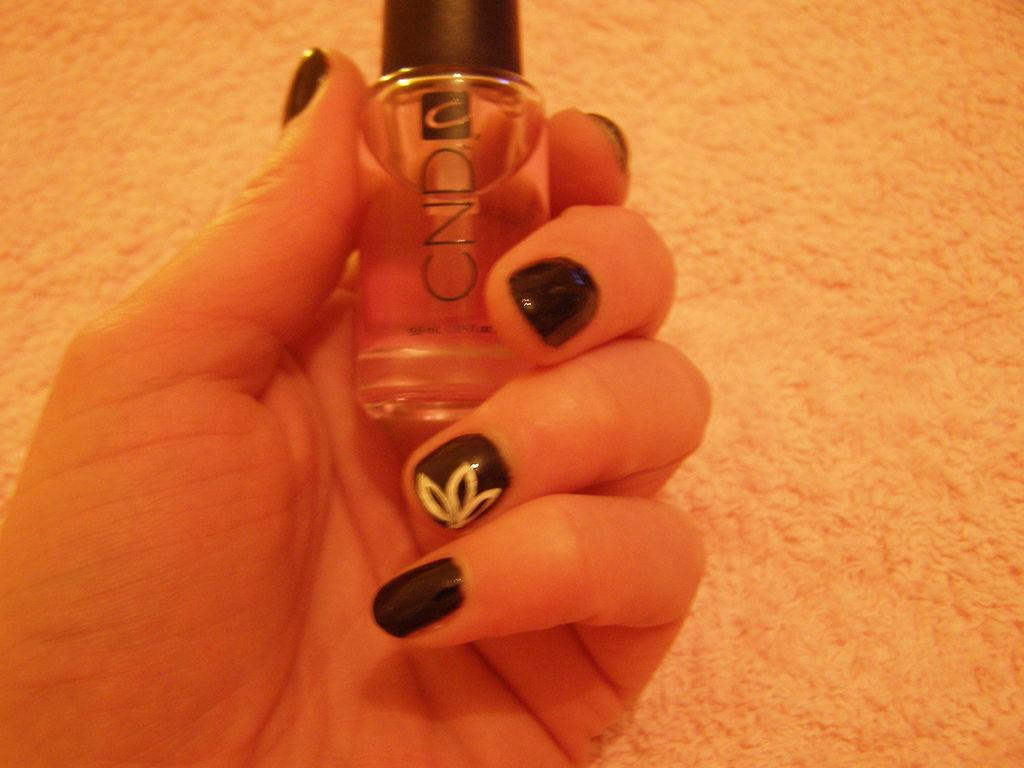<image>
Write a terse but informative summary of the picture. A woman holds a small bottle of a CND product in her left hand. 